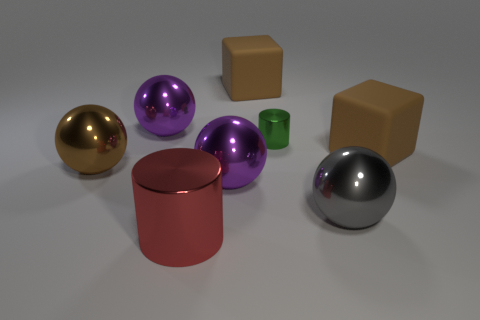Is there anything else that is the same size as the green thing?
Your answer should be compact. No. There is a large sphere that is behind the green metal cylinder; what is its material?
Your answer should be very brief. Metal. There is a green thing that is the same material as the large red cylinder; what size is it?
Offer a terse response. Small. Are there any large gray things behind the brown ball?
Make the answer very short. No. What is the size of the other metallic object that is the same shape as the red metallic object?
Your answer should be compact. Small. There is a tiny thing; is it the same color as the matte object that is on the right side of the green metal object?
Provide a succinct answer. No. Do the large cylinder and the small metallic thing have the same color?
Give a very brief answer. No. Are there fewer tiny blue metallic objects than purple spheres?
Offer a terse response. Yes. What number of other things are the same color as the small thing?
Provide a short and direct response. 0. What number of large purple objects are there?
Your response must be concise. 2. 